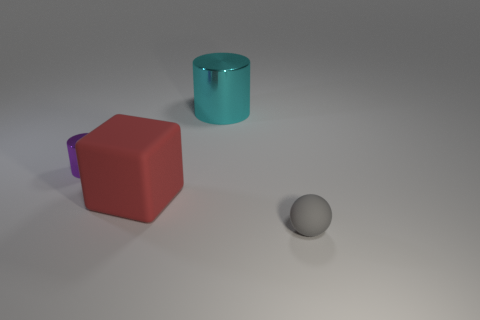Add 1 large yellow matte blocks. How many objects exist? 5 Subtract all blocks. How many objects are left? 3 Add 2 rubber spheres. How many rubber spheres are left? 3 Add 1 cyan cylinders. How many cyan cylinders exist? 2 Subtract 0 blue blocks. How many objects are left? 4 Subtract all cylinders. Subtract all gray things. How many objects are left? 1 